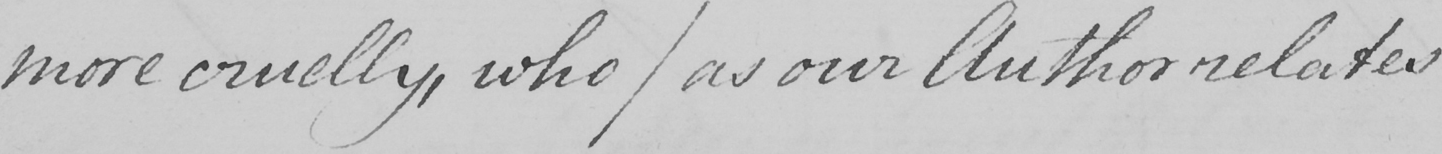What does this handwritten line say? more cruelly , who  ( as our Author relates 